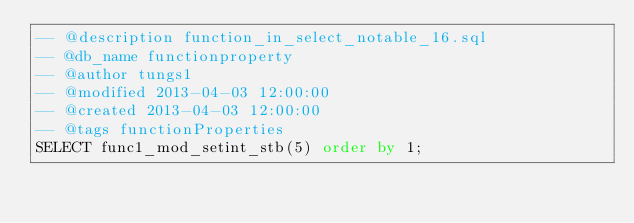<code> <loc_0><loc_0><loc_500><loc_500><_SQL_>-- @description function_in_select_notable_16.sql
-- @db_name functionproperty
-- @author tungs1
-- @modified 2013-04-03 12:00:00
-- @created 2013-04-03 12:00:00
-- @tags functionProperties 
SELECT func1_mod_setint_stb(5) order by 1; 
</code> 